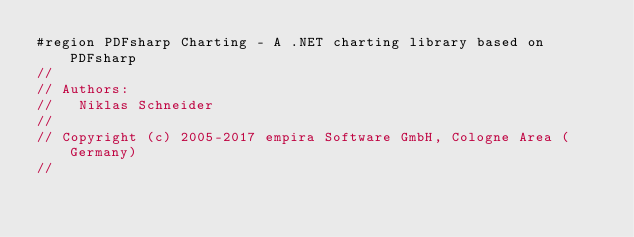Convert code to text. <code><loc_0><loc_0><loc_500><loc_500><_C#_>#region PDFsharp Charting - A .NET charting library based on PDFsharp
//
// Authors:
//   Niklas Schneider
//
// Copyright (c) 2005-2017 empira Software GmbH, Cologne Area (Germany)
//</code> 